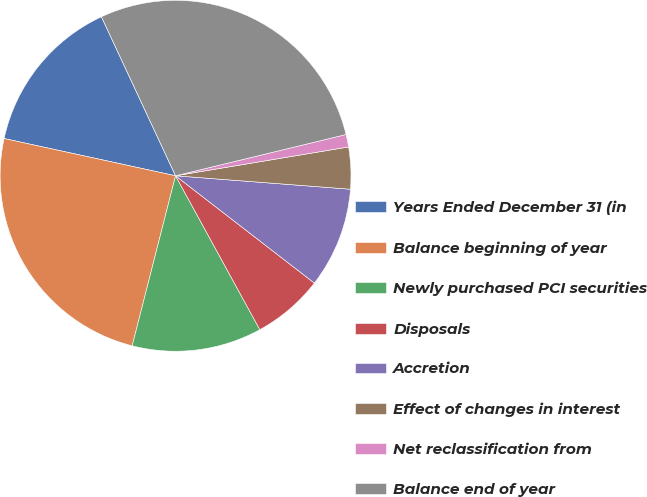Convert chart. <chart><loc_0><loc_0><loc_500><loc_500><pie_chart><fcel>Years Ended December 31 (in<fcel>Balance beginning of year<fcel>Newly purchased PCI securities<fcel>Disposals<fcel>Accretion<fcel>Effect of changes in interest<fcel>Net reclassification from<fcel>Balance end of year<nl><fcel>14.65%<fcel>24.43%<fcel>11.95%<fcel>6.55%<fcel>9.25%<fcel>3.85%<fcel>1.15%<fcel>28.16%<nl></chart> 